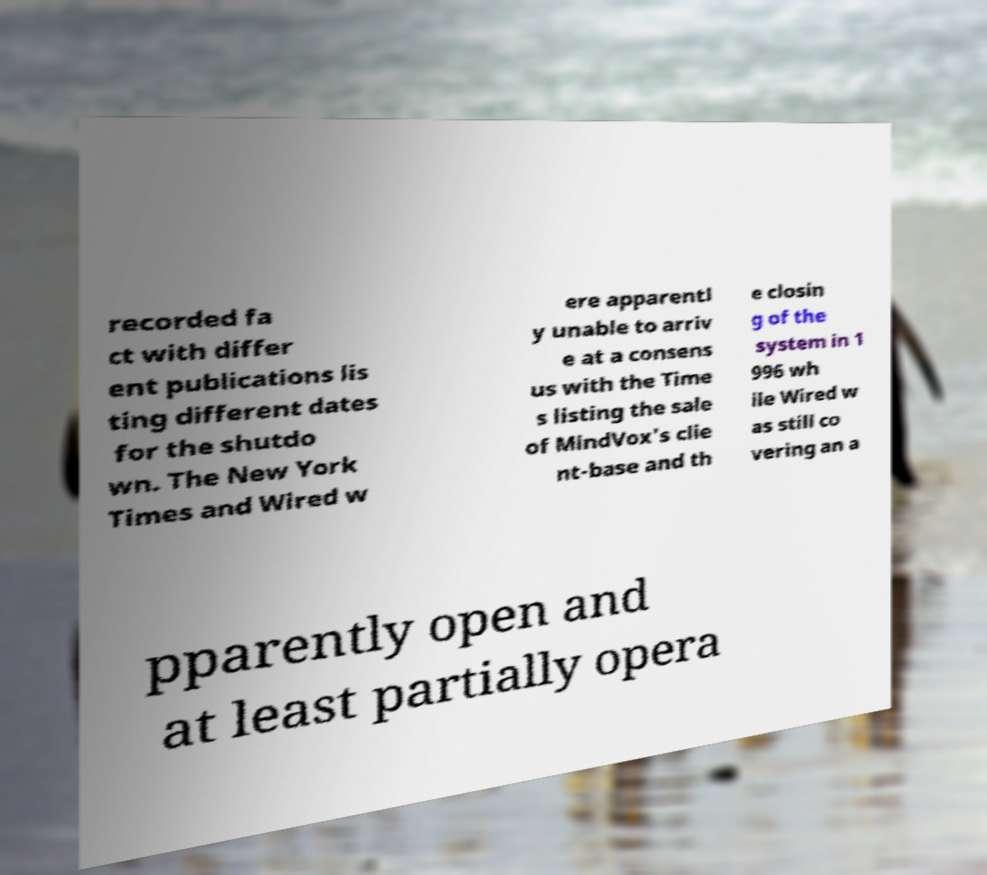I need the written content from this picture converted into text. Can you do that? recorded fa ct with differ ent publications lis ting different dates for the shutdo wn. The New York Times and Wired w ere apparentl y unable to arriv e at a consens us with the Time s listing the sale of MindVox's clie nt-base and th e closin g of the system in 1 996 wh ile Wired w as still co vering an a pparently open and at least partially opera 